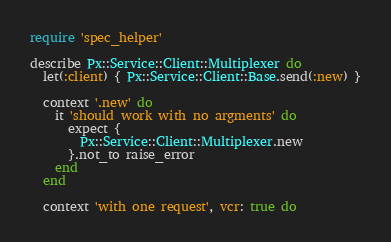Convert code to text. <code><loc_0><loc_0><loc_500><loc_500><_Ruby_>require 'spec_helper'

describe Px::Service::Client::Multiplexer do
  let(:client) { Px::Service::Client::Base.send(:new) }

  context '.new' do
    it 'should work with no argments' do
      expect {
        Px::Service::Client::Multiplexer.new
      }.not_to raise_error
    end
  end

  context 'with one request', vcr: true do</code> 